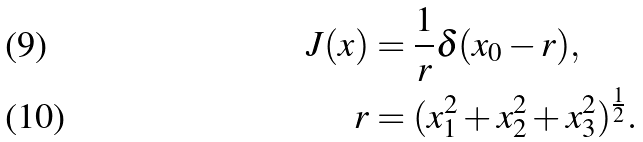<formula> <loc_0><loc_0><loc_500><loc_500>J ( x ) & = \frac { 1 } { r } \delta ( x _ { 0 } - r ) , \\ r & = ( x _ { 1 } ^ { 2 } + x _ { 2 } ^ { 2 } + x _ { 3 } ^ { 2 } ) ^ { \frac { 1 } { 2 } } .</formula> 